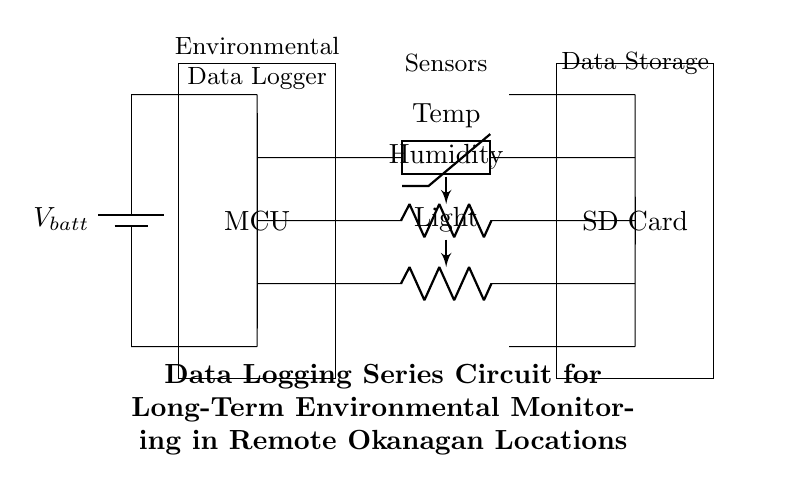What is the main component of this circuit? The main component is the microcontroller unit (MCU), which processes the signals from the sensors and manages data storage.
Answer: microcontroller unit How many sensors are present in the circuit? There are three sensors—thermistor for temperature, a resistive sensor for humidity, and a resistive sensor for light.
Answer: three What type of data storage is utilized in this circuit? The circuit uses an SD card for data storage, which allows for long-term storage of environmental measurements.
Answer: SD card What does the thermistor measure? The thermistor measures temperature, as indicated by its label in the circuit diagram.
Answer: temperature Why is the microcontroller essential in this circuit? The microcontroller is essential because it collects data from the sensors and controls the data logging process to the SD card, making it the central processing unit of the circuit.
Answer: central processing unit What is the overall purpose of this circuit? The overall purpose of the circuit is to log environmental data in remote locations over a long-term period, contributing to ecological research.
Answer: log environmental data What components connect the MCU to the sensors? The components that connect the MCU to the sensors are short connections (wires) that facilitate the flow of data from the sensors to the microcontroller.
Answer: short connections 